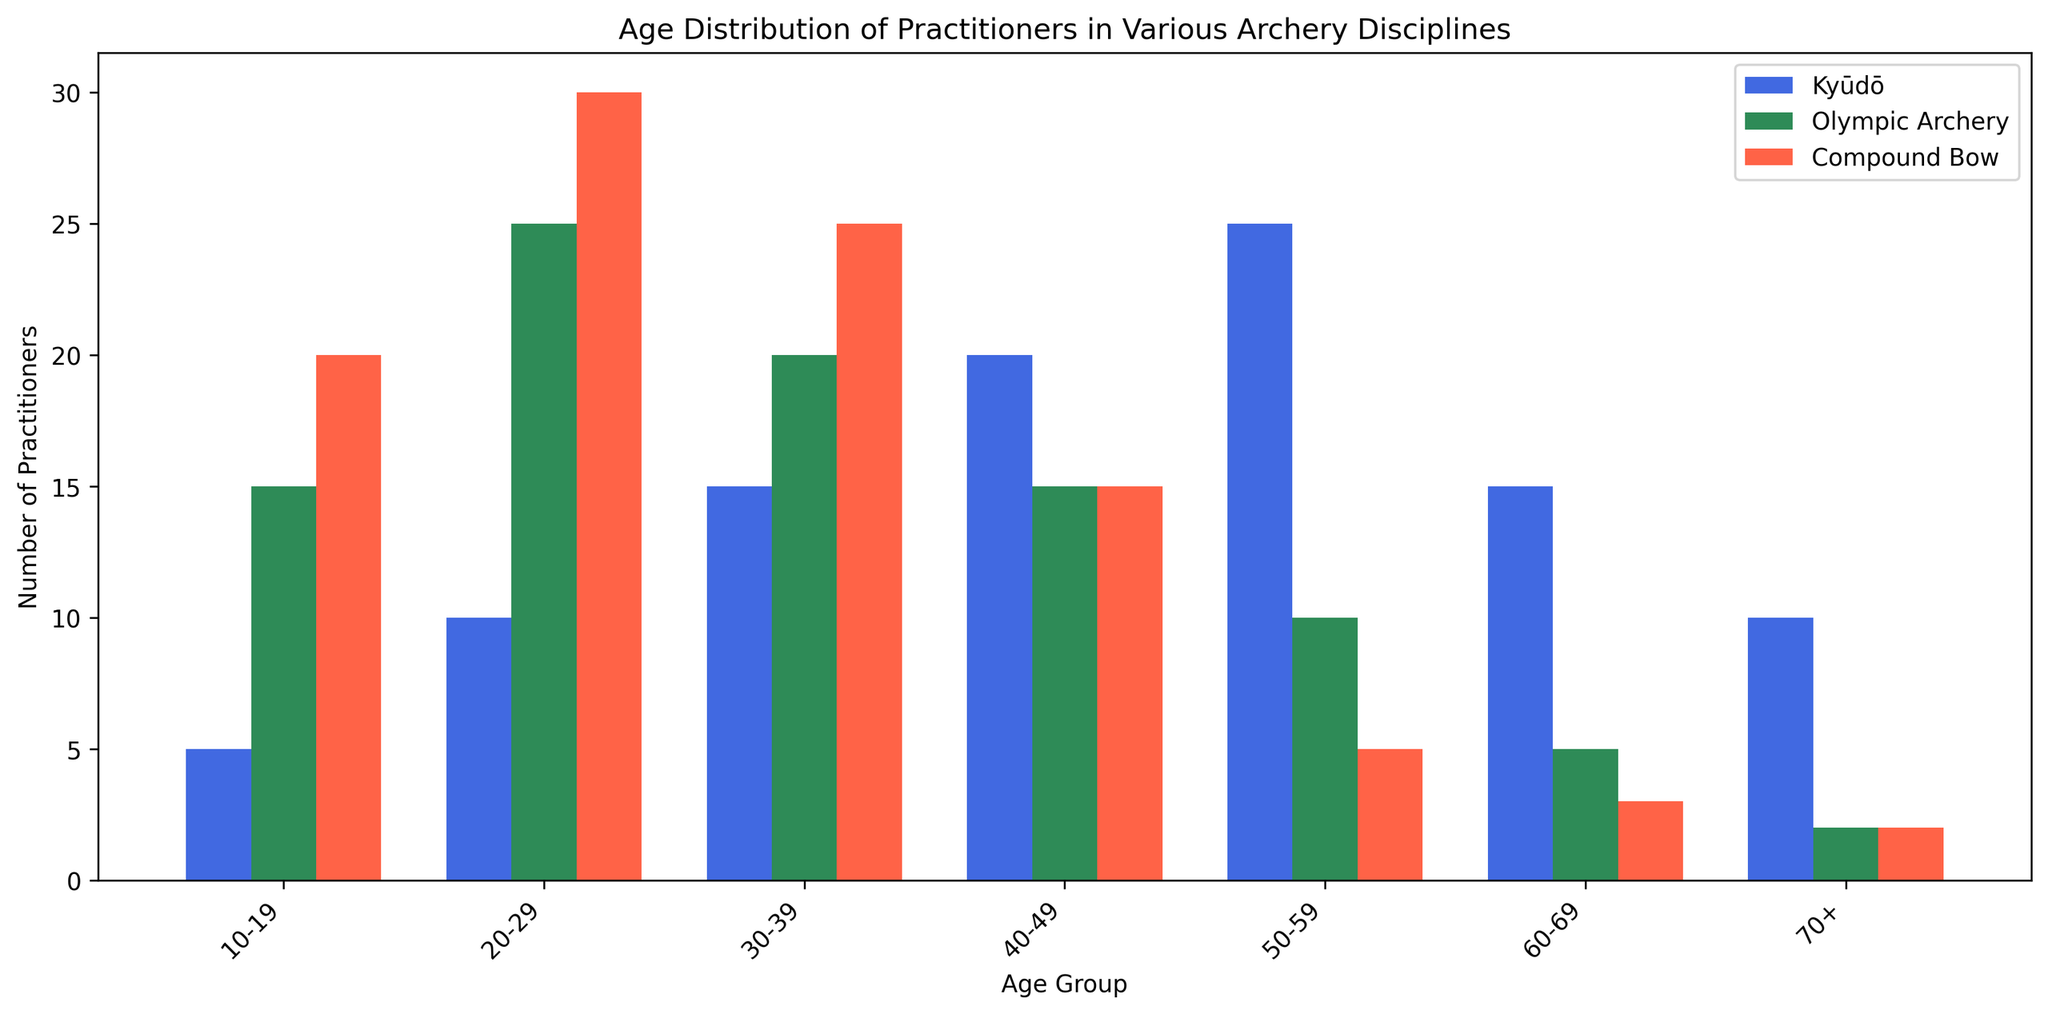Which age group has the highest number of Kyūdō practitioners? Examine the bar heights for Kyūdō practitioners and compare. The tallest bar corresponds to the 50-59 age group.
Answer: 50-59 How many more practitioners are there in Kyūdō than in Olympic Archery in the 50-59 age group? Look at the bar heights for the 50-59 age group in Kyūdō and Olympic Archery. Kyūdō has 25 practitioners, and Olympic Archery has 10. Subtract 10 from 25.
Answer: 15 What is the combined total number of practitioners for all disciplines in the 20-29 age group? Add up the numbers of practitioners in the 20-29 age group for Kyūdō (10), Olympic Archery (25), and Compound Bow (30). The sum is 10 + 25 + 30.
Answer: 65 Which discipline has the fewest practitioners in the 70+ age group, and how many are there? Compare the heights of the bars for the 70+ age group. The smallest bar is for Olympic Archery, with 2 practitioners.
Answer: Olympic Archery, 2 In which age group is the number of Compound Bow practitioners greater than the number of Kyūdō practitioners, but fewer than Olympic Archery practitioners? Compare the bar heights for each age group and find where Compound Bow's bar is between Kyūdō's and Olympic Archery's bars. In the 20-29 age group, Compound Bow has 30 practitioners, more than Kyūdō (10) and fewer than Olympic Archery (25).
Answer: 20-29 What is the average number of practitioners across all disciplines in the 60-69 age group? Add the number of practitioners for Kyūdō (15), Olympic Archery (5), and Compound Bow (3). Divide by the number of disciplines (3). (15 + 5 + 3) / 3 = 7.67
Answer: 7.67 Between the age groups 40-49 and 60-69, which one has a higher total number of practitioners for Olympic Archery? Look at the total number of practitioners for Olympic Archery in the 40-49 (15) and 60-69 (5) age groups. The 40-49 age group has a higher number.
Answer: 40-49 What is the difference in the number of practitioners between Kyūdō and Compound Bow in the 30-39 age group? Compare the number of practitioners in the 30-39 age group for Kyūdō (15) and Compound Bow (25). Subtract 15 from 25.
Answer: 10 Which discipline has the most evenly distributed number of practitioners across all age groups? Analyze the consistency in bar heights across age groups for each discipline. Kyūdō's bars are the most evenly distributed.
Answer: Kyūdō 